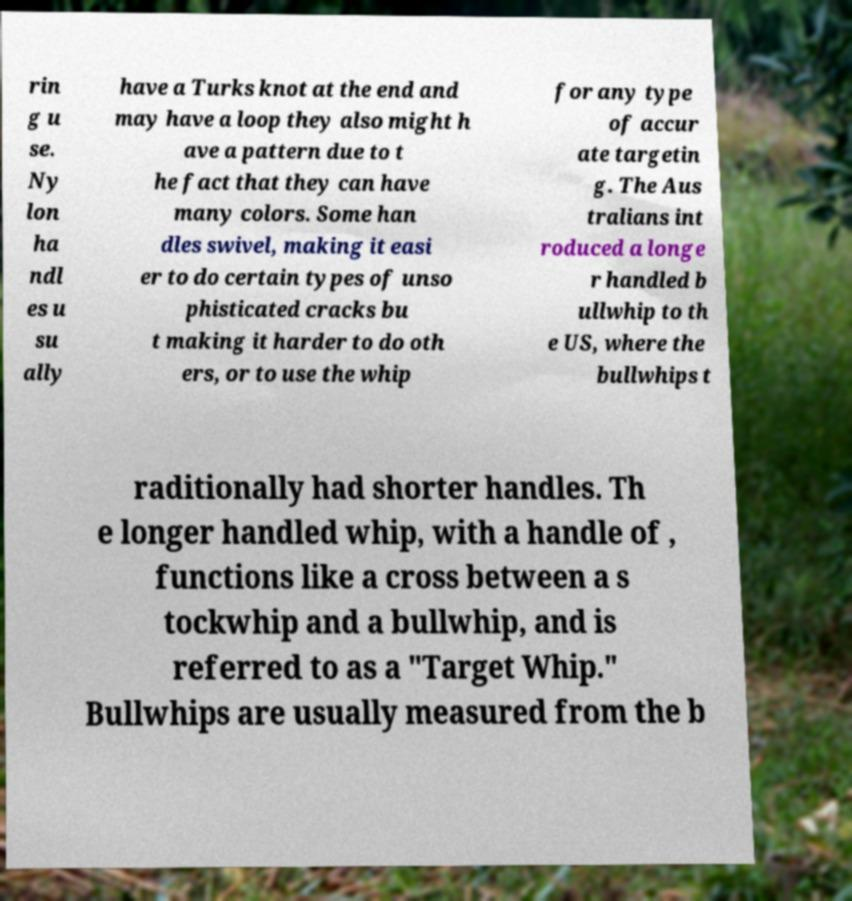What messages or text are displayed in this image? I need them in a readable, typed format. rin g u se. Ny lon ha ndl es u su ally have a Turks knot at the end and may have a loop they also might h ave a pattern due to t he fact that they can have many colors. Some han dles swivel, making it easi er to do certain types of unso phisticated cracks bu t making it harder to do oth ers, or to use the whip for any type of accur ate targetin g. The Aus tralians int roduced a longe r handled b ullwhip to th e US, where the bullwhips t raditionally had shorter handles. Th e longer handled whip, with a handle of , functions like a cross between a s tockwhip and a bullwhip, and is referred to as a "Target Whip." Bullwhips are usually measured from the b 